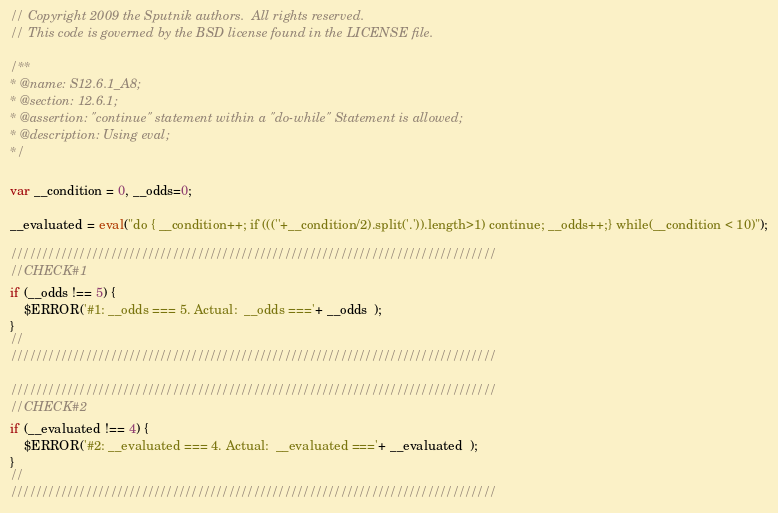<code> <loc_0><loc_0><loc_500><loc_500><_JavaScript_>// Copyright 2009 the Sputnik authors.  All rights reserved.
// This code is governed by the BSD license found in the LICENSE file.

/**
* @name: S12.6.1_A8;
* @section: 12.6.1;
* @assertion: "continue" statement within a "do-while" Statement is allowed;
* @description: Using eval;
*/

var __condition = 0, __odds=0;

__evaluated = eval("do { __condition++; if (((''+__condition/2).split('.')).length>1) continue; __odds++;} while(__condition < 10)");

//////////////////////////////////////////////////////////////////////////////
//CHECK#1
if (__odds !== 5) {
	$ERROR('#1: __odds === 5. Actual:  __odds ==='+ __odds  );
}
//
//////////////////////////////////////////////////////////////////////////////

//////////////////////////////////////////////////////////////////////////////
//CHECK#2
if (__evaluated !== 4) {
	$ERROR('#2: __evaluated === 4. Actual:  __evaluated ==='+ __evaluated  );
}
//
//////////////////////////////////////////////////////////////////////////////

</code> 